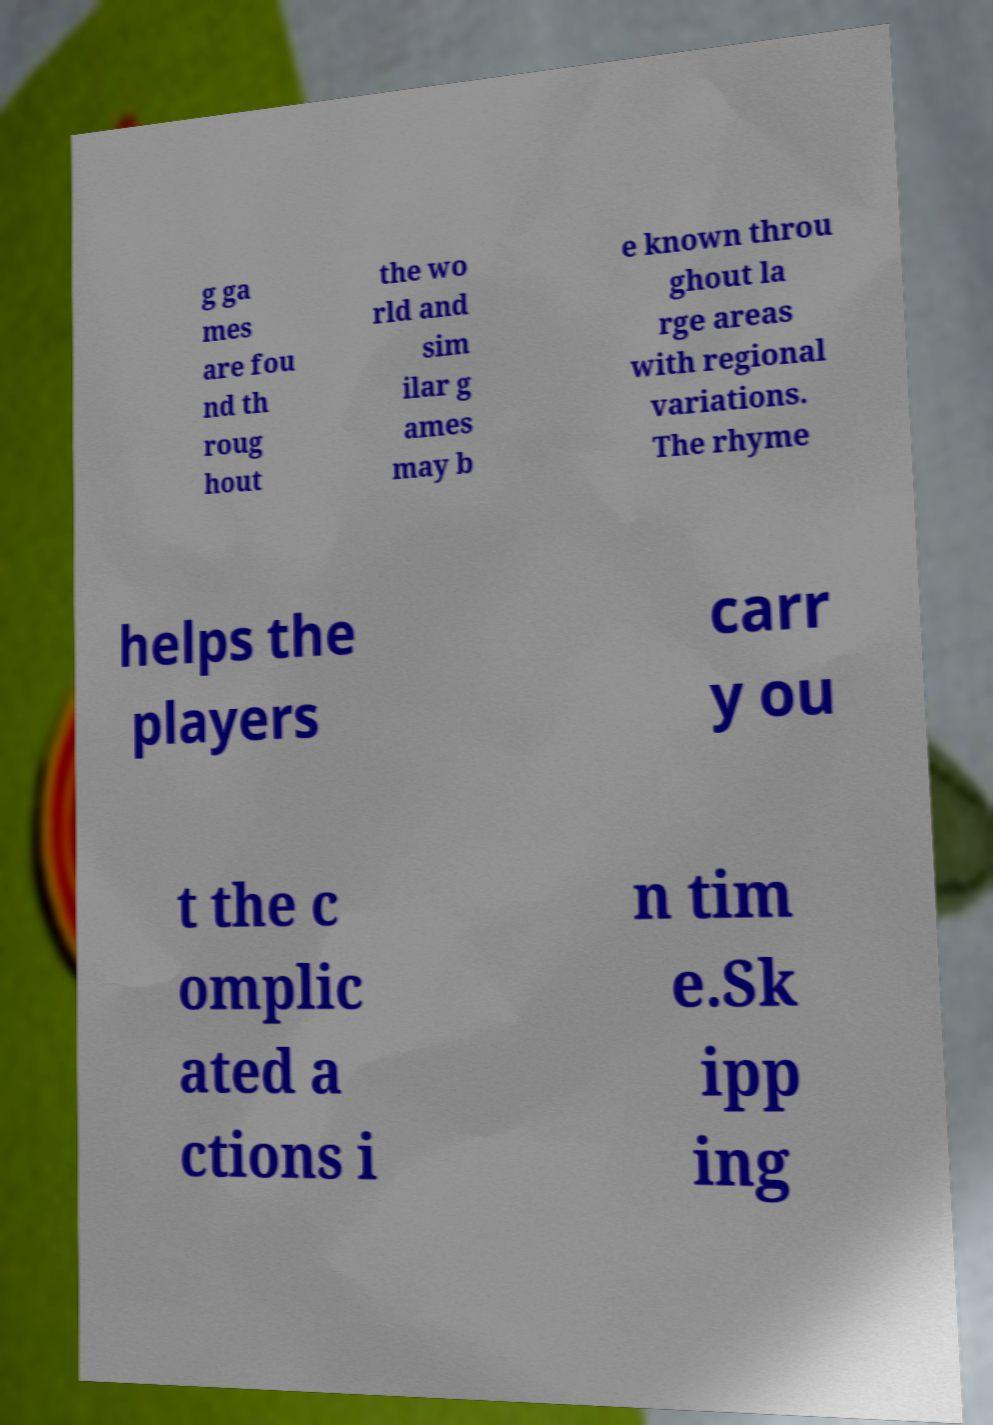Please read and relay the text visible in this image. What does it say? g ga mes are fou nd th roug hout the wo rld and sim ilar g ames may b e known throu ghout la rge areas with regional variations. The rhyme helps the players carr y ou t the c omplic ated a ctions i n tim e.Sk ipp ing 